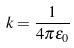Convert formula to latex. <formula><loc_0><loc_0><loc_500><loc_500>k = \frac { 1 } { 4 \pi \epsilon _ { 0 } }</formula> 